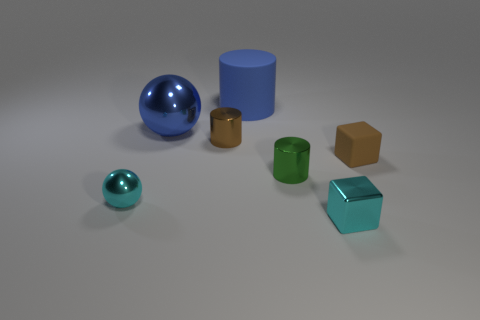Subtract all large cylinders. How many cylinders are left? 2 Subtract all green cylinders. How many cylinders are left? 2 Add 3 blue shiny things. How many objects exist? 10 Subtract all cylinders. How many objects are left? 4 Subtract 1 blocks. How many blocks are left? 1 Subtract all gray balls. How many brown cylinders are left? 1 Subtract all matte objects. Subtract all blue matte cylinders. How many objects are left? 4 Add 4 small brown shiny cylinders. How many small brown shiny cylinders are left? 5 Add 5 big green metallic things. How many big green metallic things exist? 5 Subtract 1 cyan blocks. How many objects are left? 6 